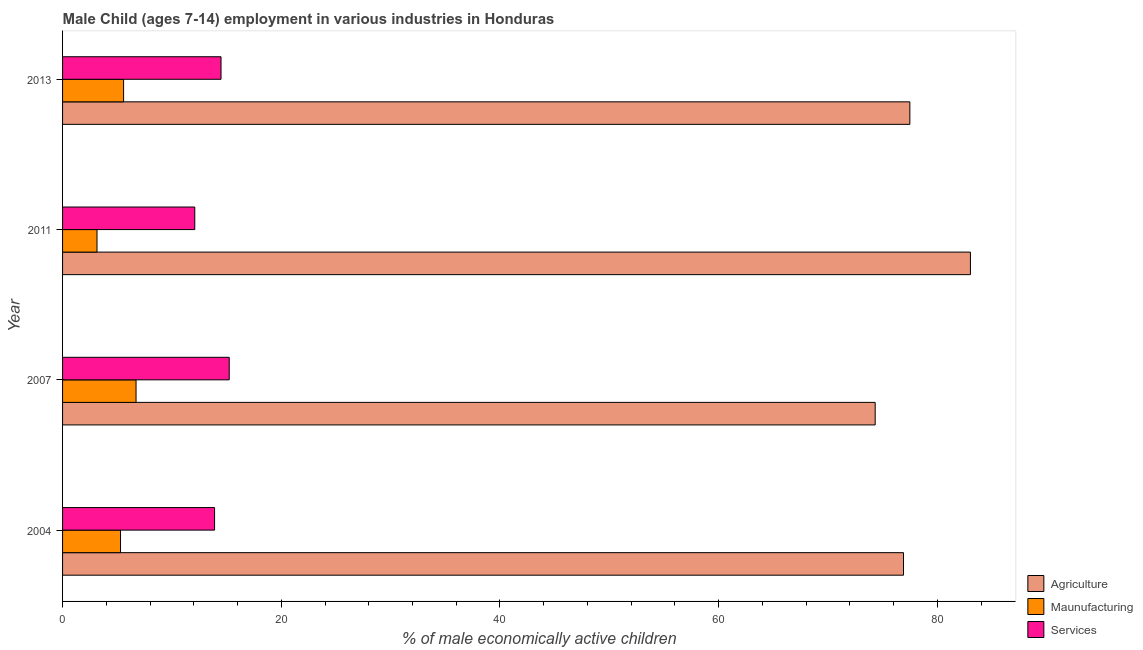How many different coloured bars are there?
Give a very brief answer. 3. Are the number of bars per tick equal to the number of legend labels?
Your response must be concise. Yes. How many bars are there on the 4th tick from the top?
Keep it short and to the point. 3. Across all years, what is the maximum percentage of economically active children in manufacturing?
Ensure brevity in your answer.  6.72. Across all years, what is the minimum percentage of economically active children in agriculture?
Your answer should be very brief. 74.31. What is the total percentage of economically active children in manufacturing in the graph?
Your answer should be compact. 20.75. What is the difference between the percentage of economically active children in agriculture in 2007 and that in 2011?
Offer a very short reply. -8.71. What is the difference between the percentage of economically active children in agriculture in 2007 and the percentage of economically active children in manufacturing in 2011?
Provide a succinct answer. 71.16. What is the average percentage of economically active children in agriculture per year?
Provide a succinct answer. 77.93. In the year 2007, what is the difference between the percentage of economically active children in agriculture and percentage of economically active children in services?
Offer a terse response. 59.07. Is the percentage of economically active children in manufacturing in 2011 less than that in 2013?
Give a very brief answer. Yes. Is the difference between the percentage of economically active children in services in 2004 and 2013 greater than the difference between the percentage of economically active children in agriculture in 2004 and 2013?
Make the answer very short. No. What is the difference between the highest and the second highest percentage of economically active children in agriculture?
Your response must be concise. 5.54. What is the difference between the highest and the lowest percentage of economically active children in manufacturing?
Ensure brevity in your answer.  3.57. What does the 3rd bar from the top in 2004 represents?
Offer a very short reply. Agriculture. What does the 3rd bar from the bottom in 2007 represents?
Keep it short and to the point. Services. Is it the case that in every year, the sum of the percentage of economically active children in agriculture and percentage of economically active children in manufacturing is greater than the percentage of economically active children in services?
Offer a very short reply. Yes. How many years are there in the graph?
Provide a succinct answer. 4. What is the difference between two consecutive major ticks on the X-axis?
Your answer should be compact. 20. How many legend labels are there?
Provide a short and direct response. 3. How are the legend labels stacked?
Ensure brevity in your answer.  Vertical. What is the title of the graph?
Your answer should be compact. Male Child (ages 7-14) employment in various industries in Honduras. What is the label or title of the X-axis?
Offer a very short reply. % of male economically active children. What is the % of male economically active children in Agriculture in 2004?
Offer a very short reply. 76.9. What is the % of male economically active children of Agriculture in 2007?
Your response must be concise. 74.31. What is the % of male economically active children of Maunufacturing in 2007?
Your answer should be compact. 6.72. What is the % of male economically active children in Services in 2007?
Your answer should be compact. 15.24. What is the % of male economically active children in Agriculture in 2011?
Your response must be concise. 83.02. What is the % of male economically active children of Maunufacturing in 2011?
Your response must be concise. 3.15. What is the % of male economically active children of Services in 2011?
Provide a short and direct response. 12.09. What is the % of male economically active children in Agriculture in 2013?
Make the answer very short. 77.48. What is the % of male economically active children in Maunufacturing in 2013?
Keep it short and to the point. 5.58. What is the % of male economically active children of Services in 2013?
Provide a short and direct response. 14.49. Across all years, what is the maximum % of male economically active children of Agriculture?
Your answer should be compact. 83.02. Across all years, what is the maximum % of male economically active children in Maunufacturing?
Offer a terse response. 6.72. Across all years, what is the maximum % of male economically active children of Services?
Your response must be concise. 15.24. Across all years, what is the minimum % of male economically active children in Agriculture?
Give a very brief answer. 74.31. Across all years, what is the minimum % of male economically active children in Maunufacturing?
Provide a succinct answer. 3.15. Across all years, what is the minimum % of male economically active children in Services?
Provide a succinct answer. 12.09. What is the total % of male economically active children of Agriculture in the graph?
Your answer should be compact. 311.71. What is the total % of male economically active children of Maunufacturing in the graph?
Your answer should be compact. 20.75. What is the total % of male economically active children of Services in the graph?
Make the answer very short. 55.72. What is the difference between the % of male economically active children of Agriculture in 2004 and that in 2007?
Ensure brevity in your answer.  2.59. What is the difference between the % of male economically active children of Maunufacturing in 2004 and that in 2007?
Keep it short and to the point. -1.42. What is the difference between the % of male economically active children in Services in 2004 and that in 2007?
Provide a short and direct response. -1.34. What is the difference between the % of male economically active children of Agriculture in 2004 and that in 2011?
Provide a short and direct response. -6.12. What is the difference between the % of male economically active children of Maunufacturing in 2004 and that in 2011?
Your response must be concise. 2.15. What is the difference between the % of male economically active children in Services in 2004 and that in 2011?
Ensure brevity in your answer.  1.81. What is the difference between the % of male economically active children of Agriculture in 2004 and that in 2013?
Provide a succinct answer. -0.58. What is the difference between the % of male economically active children of Maunufacturing in 2004 and that in 2013?
Provide a succinct answer. -0.28. What is the difference between the % of male economically active children of Services in 2004 and that in 2013?
Your response must be concise. -0.59. What is the difference between the % of male economically active children in Agriculture in 2007 and that in 2011?
Keep it short and to the point. -8.71. What is the difference between the % of male economically active children in Maunufacturing in 2007 and that in 2011?
Provide a succinct answer. 3.57. What is the difference between the % of male economically active children of Services in 2007 and that in 2011?
Your answer should be compact. 3.15. What is the difference between the % of male economically active children of Agriculture in 2007 and that in 2013?
Give a very brief answer. -3.17. What is the difference between the % of male economically active children in Maunufacturing in 2007 and that in 2013?
Provide a short and direct response. 1.14. What is the difference between the % of male economically active children of Services in 2007 and that in 2013?
Offer a terse response. 0.75. What is the difference between the % of male economically active children of Agriculture in 2011 and that in 2013?
Give a very brief answer. 5.54. What is the difference between the % of male economically active children in Maunufacturing in 2011 and that in 2013?
Ensure brevity in your answer.  -2.43. What is the difference between the % of male economically active children of Agriculture in 2004 and the % of male economically active children of Maunufacturing in 2007?
Provide a short and direct response. 70.18. What is the difference between the % of male economically active children of Agriculture in 2004 and the % of male economically active children of Services in 2007?
Offer a terse response. 61.66. What is the difference between the % of male economically active children in Maunufacturing in 2004 and the % of male economically active children in Services in 2007?
Provide a short and direct response. -9.94. What is the difference between the % of male economically active children in Agriculture in 2004 and the % of male economically active children in Maunufacturing in 2011?
Offer a terse response. 73.75. What is the difference between the % of male economically active children of Agriculture in 2004 and the % of male economically active children of Services in 2011?
Provide a succinct answer. 64.81. What is the difference between the % of male economically active children of Maunufacturing in 2004 and the % of male economically active children of Services in 2011?
Offer a terse response. -6.79. What is the difference between the % of male economically active children in Agriculture in 2004 and the % of male economically active children in Maunufacturing in 2013?
Your answer should be very brief. 71.32. What is the difference between the % of male economically active children in Agriculture in 2004 and the % of male economically active children in Services in 2013?
Keep it short and to the point. 62.41. What is the difference between the % of male economically active children of Maunufacturing in 2004 and the % of male economically active children of Services in 2013?
Ensure brevity in your answer.  -9.19. What is the difference between the % of male economically active children in Agriculture in 2007 and the % of male economically active children in Maunufacturing in 2011?
Provide a short and direct response. 71.16. What is the difference between the % of male economically active children of Agriculture in 2007 and the % of male economically active children of Services in 2011?
Offer a very short reply. 62.22. What is the difference between the % of male economically active children of Maunufacturing in 2007 and the % of male economically active children of Services in 2011?
Your response must be concise. -5.37. What is the difference between the % of male economically active children of Agriculture in 2007 and the % of male economically active children of Maunufacturing in 2013?
Offer a very short reply. 68.73. What is the difference between the % of male economically active children in Agriculture in 2007 and the % of male economically active children in Services in 2013?
Give a very brief answer. 59.82. What is the difference between the % of male economically active children of Maunufacturing in 2007 and the % of male economically active children of Services in 2013?
Provide a succinct answer. -7.77. What is the difference between the % of male economically active children in Agriculture in 2011 and the % of male economically active children in Maunufacturing in 2013?
Offer a very short reply. 77.44. What is the difference between the % of male economically active children in Agriculture in 2011 and the % of male economically active children in Services in 2013?
Your answer should be very brief. 68.53. What is the difference between the % of male economically active children of Maunufacturing in 2011 and the % of male economically active children of Services in 2013?
Keep it short and to the point. -11.34. What is the average % of male economically active children in Agriculture per year?
Ensure brevity in your answer.  77.93. What is the average % of male economically active children of Maunufacturing per year?
Make the answer very short. 5.19. What is the average % of male economically active children of Services per year?
Your answer should be very brief. 13.93. In the year 2004, what is the difference between the % of male economically active children of Agriculture and % of male economically active children of Maunufacturing?
Offer a very short reply. 71.6. In the year 2004, what is the difference between the % of male economically active children of Maunufacturing and % of male economically active children of Services?
Your answer should be very brief. -8.6. In the year 2007, what is the difference between the % of male economically active children of Agriculture and % of male economically active children of Maunufacturing?
Provide a short and direct response. 67.59. In the year 2007, what is the difference between the % of male economically active children in Agriculture and % of male economically active children in Services?
Make the answer very short. 59.07. In the year 2007, what is the difference between the % of male economically active children in Maunufacturing and % of male economically active children in Services?
Offer a terse response. -8.52. In the year 2011, what is the difference between the % of male economically active children of Agriculture and % of male economically active children of Maunufacturing?
Your response must be concise. 79.87. In the year 2011, what is the difference between the % of male economically active children in Agriculture and % of male economically active children in Services?
Offer a very short reply. 70.93. In the year 2011, what is the difference between the % of male economically active children in Maunufacturing and % of male economically active children in Services?
Provide a succinct answer. -8.94. In the year 2013, what is the difference between the % of male economically active children of Agriculture and % of male economically active children of Maunufacturing?
Offer a very short reply. 71.9. In the year 2013, what is the difference between the % of male economically active children of Agriculture and % of male economically active children of Services?
Make the answer very short. 62.99. In the year 2013, what is the difference between the % of male economically active children in Maunufacturing and % of male economically active children in Services?
Your response must be concise. -8.91. What is the ratio of the % of male economically active children in Agriculture in 2004 to that in 2007?
Give a very brief answer. 1.03. What is the ratio of the % of male economically active children of Maunufacturing in 2004 to that in 2007?
Keep it short and to the point. 0.79. What is the ratio of the % of male economically active children of Services in 2004 to that in 2007?
Your answer should be very brief. 0.91. What is the ratio of the % of male economically active children in Agriculture in 2004 to that in 2011?
Make the answer very short. 0.93. What is the ratio of the % of male economically active children of Maunufacturing in 2004 to that in 2011?
Offer a terse response. 1.68. What is the ratio of the % of male economically active children of Services in 2004 to that in 2011?
Offer a very short reply. 1.15. What is the ratio of the % of male economically active children of Agriculture in 2004 to that in 2013?
Give a very brief answer. 0.99. What is the ratio of the % of male economically active children in Maunufacturing in 2004 to that in 2013?
Your answer should be very brief. 0.95. What is the ratio of the % of male economically active children in Services in 2004 to that in 2013?
Give a very brief answer. 0.96. What is the ratio of the % of male economically active children of Agriculture in 2007 to that in 2011?
Your answer should be very brief. 0.9. What is the ratio of the % of male economically active children in Maunufacturing in 2007 to that in 2011?
Ensure brevity in your answer.  2.13. What is the ratio of the % of male economically active children in Services in 2007 to that in 2011?
Make the answer very short. 1.26. What is the ratio of the % of male economically active children of Agriculture in 2007 to that in 2013?
Your answer should be very brief. 0.96. What is the ratio of the % of male economically active children in Maunufacturing in 2007 to that in 2013?
Your answer should be compact. 1.2. What is the ratio of the % of male economically active children in Services in 2007 to that in 2013?
Make the answer very short. 1.05. What is the ratio of the % of male economically active children of Agriculture in 2011 to that in 2013?
Your answer should be compact. 1.07. What is the ratio of the % of male economically active children in Maunufacturing in 2011 to that in 2013?
Provide a short and direct response. 0.56. What is the ratio of the % of male economically active children of Services in 2011 to that in 2013?
Offer a very short reply. 0.83. What is the difference between the highest and the second highest % of male economically active children of Agriculture?
Give a very brief answer. 5.54. What is the difference between the highest and the second highest % of male economically active children in Maunufacturing?
Make the answer very short. 1.14. What is the difference between the highest and the lowest % of male economically active children in Agriculture?
Make the answer very short. 8.71. What is the difference between the highest and the lowest % of male economically active children of Maunufacturing?
Provide a succinct answer. 3.57. What is the difference between the highest and the lowest % of male economically active children of Services?
Ensure brevity in your answer.  3.15. 